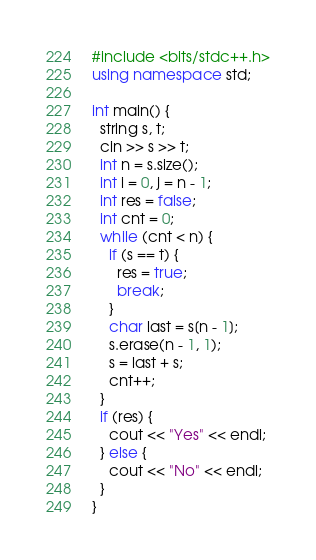Convert code to text. <code><loc_0><loc_0><loc_500><loc_500><_C++_>#include <bits/stdc++.h>
using namespace std;

int main() {
  string s, t;
  cin >> s >> t;
  int n = s.size();
  int i = 0, j = n - 1;
  int res = false;
  int cnt = 0;
  while (cnt < n) {
    if (s == t) {
      res = true;
      break;
    }
    char last = s[n - 1];
    s.erase(n - 1, 1);
    s = last + s;
    cnt++;
  }
  if (res) {
    cout << "Yes" << endl;
  } else {
    cout << "No" << endl;
  }
}</code> 